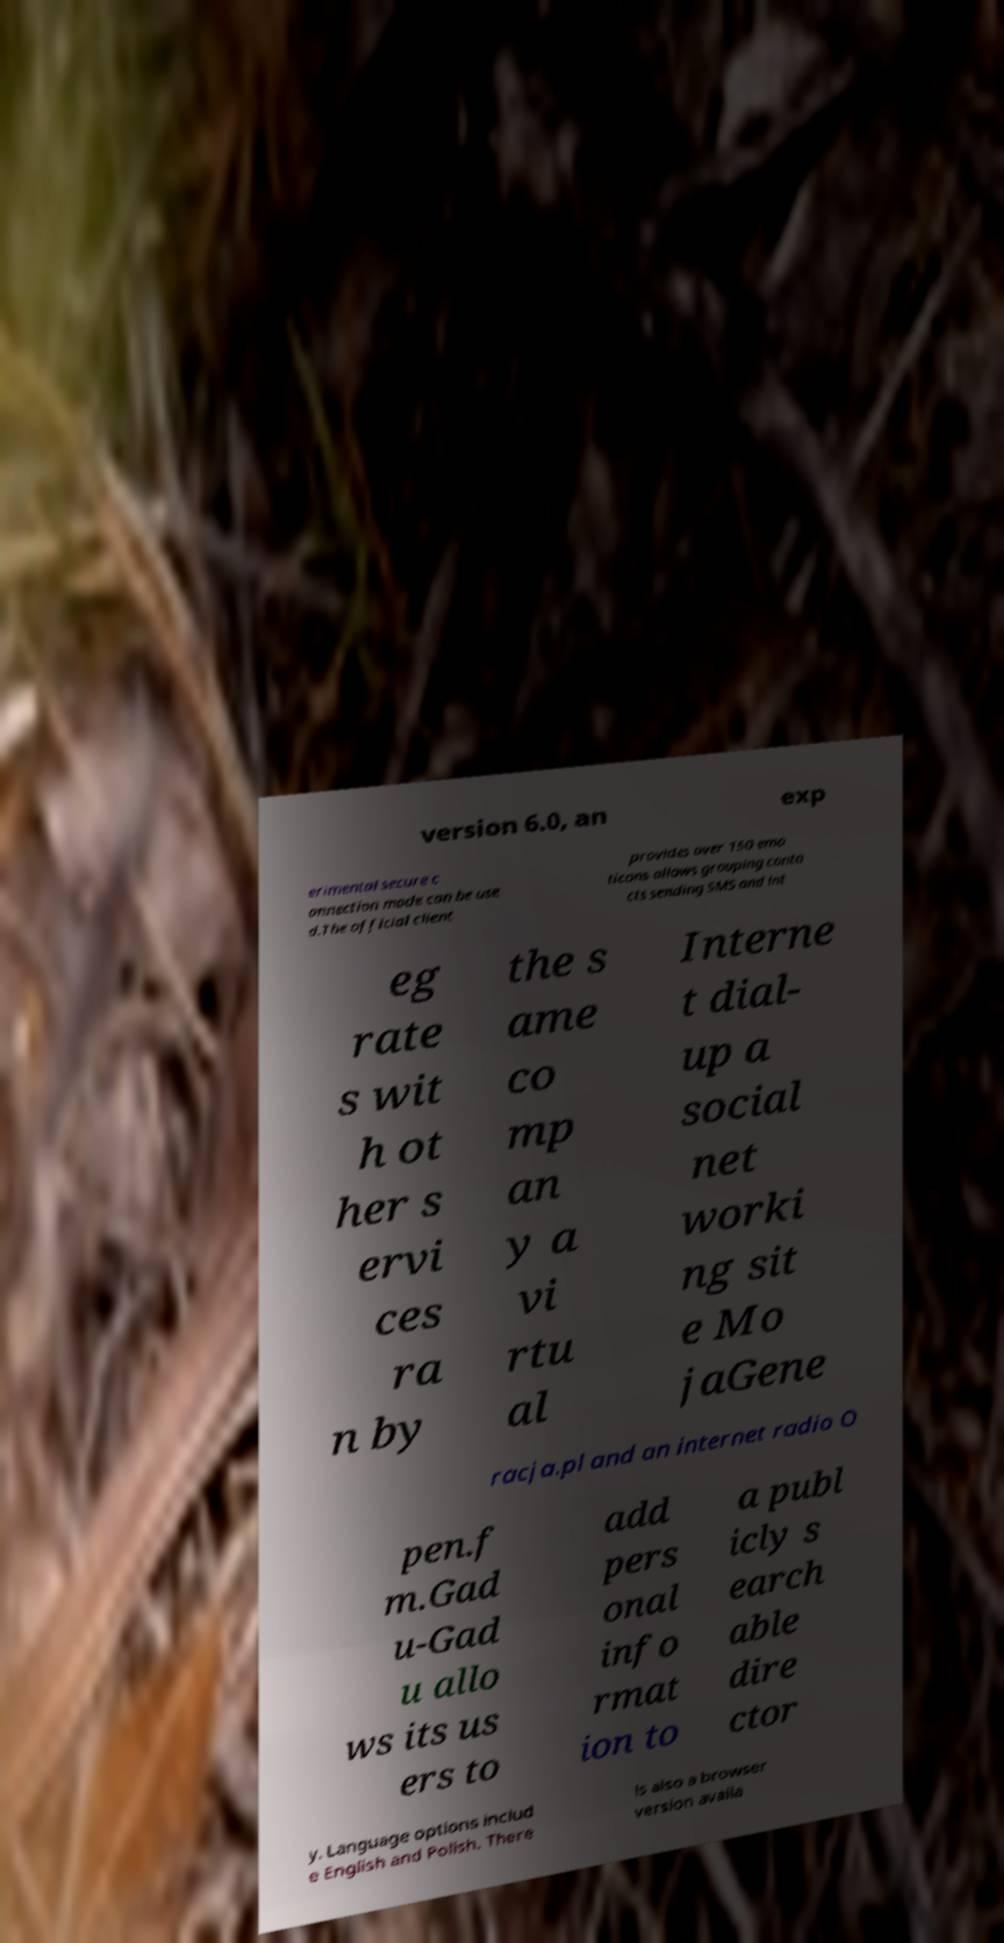Please identify and transcribe the text found in this image. version 6.0, an exp erimental secure c onnection mode can be use d.The official client provides over 150 emo ticons allows grouping conta cts sending SMS and int eg rate s wit h ot her s ervi ces ra n by the s ame co mp an y a vi rtu al Interne t dial- up a social net worki ng sit e Mo jaGene racja.pl and an internet radio O pen.f m.Gad u-Gad u allo ws its us ers to add pers onal info rmat ion to a publ icly s earch able dire ctor y. Language options includ e English and Polish. There is also a browser version availa 